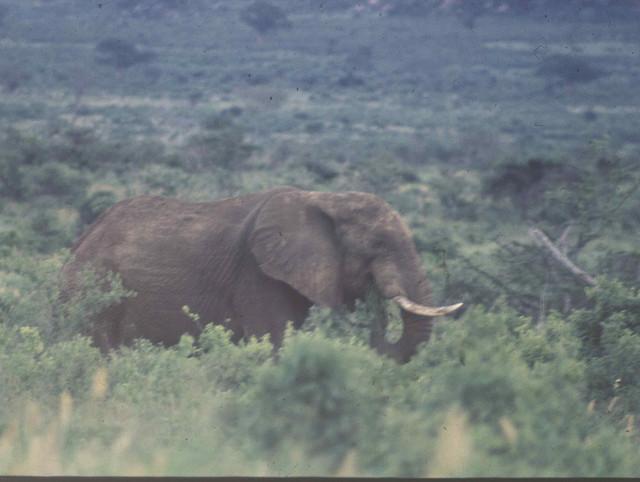How many horses are in the picture?
Give a very brief answer. 0. 